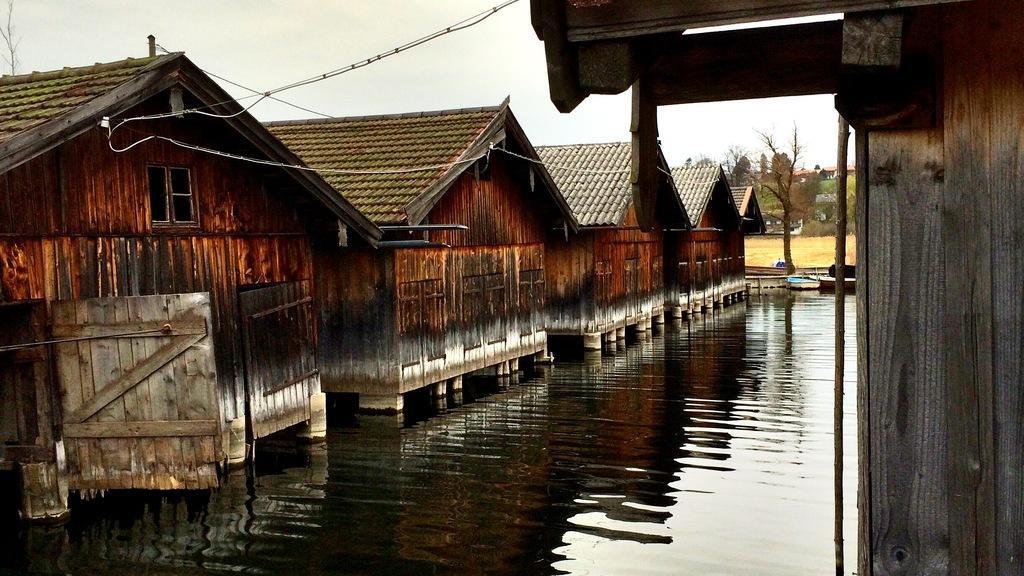Could you give a brief overview of what you see in this image? In this image, we can see sheds, wires, trees and we can see poles. At the bottom, there is water and ground. At the top, there is sky. 